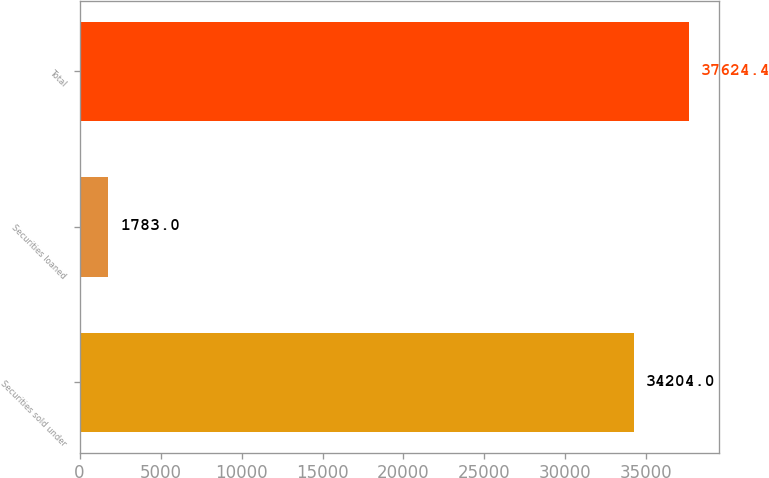Convert chart to OTSL. <chart><loc_0><loc_0><loc_500><loc_500><bar_chart><fcel>Securities sold under<fcel>Securities loaned<fcel>Total<nl><fcel>34204<fcel>1783<fcel>37624.4<nl></chart> 